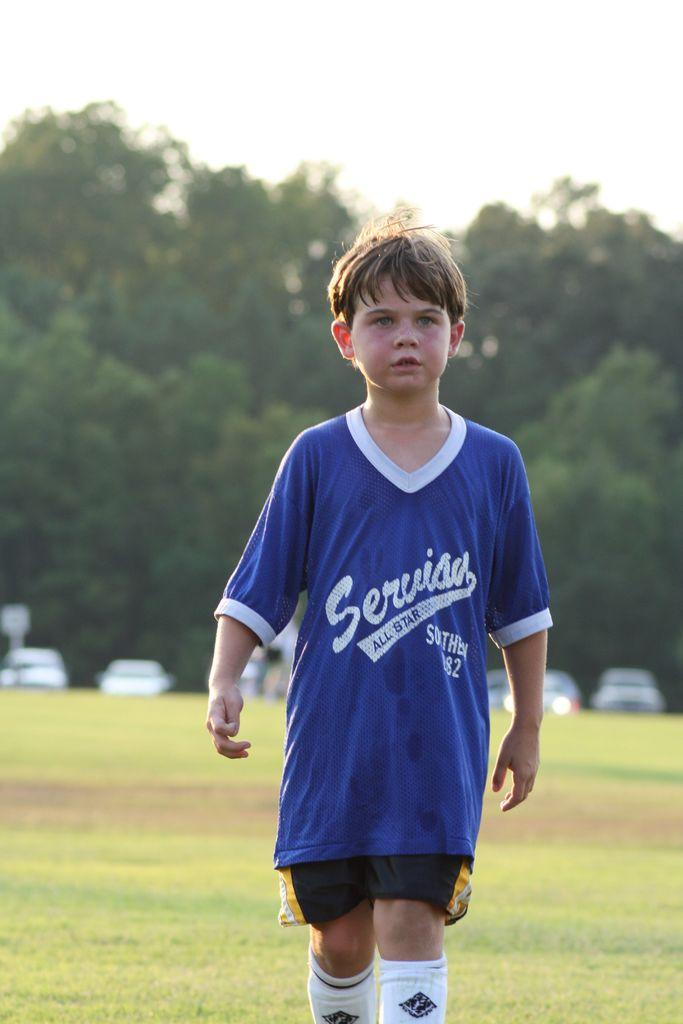<image>
Create a compact narrative representing the image presented. A boy is on a soccer field wearing a kit with All Star on the front. 